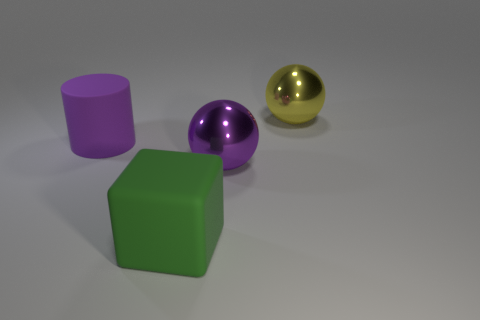Add 3 large metallic things. How many objects exist? 7 Subtract all cubes. How many objects are left? 3 Add 3 cyan balls. How many cyan balls exist? 3 Subtract 0 cyan blocks. How many objects are left? 4 Subtract all green blocks. Subtract all big purple rubber cylinders. How many objects are left? 2 Add 3 big things. How many big things are left? 7 